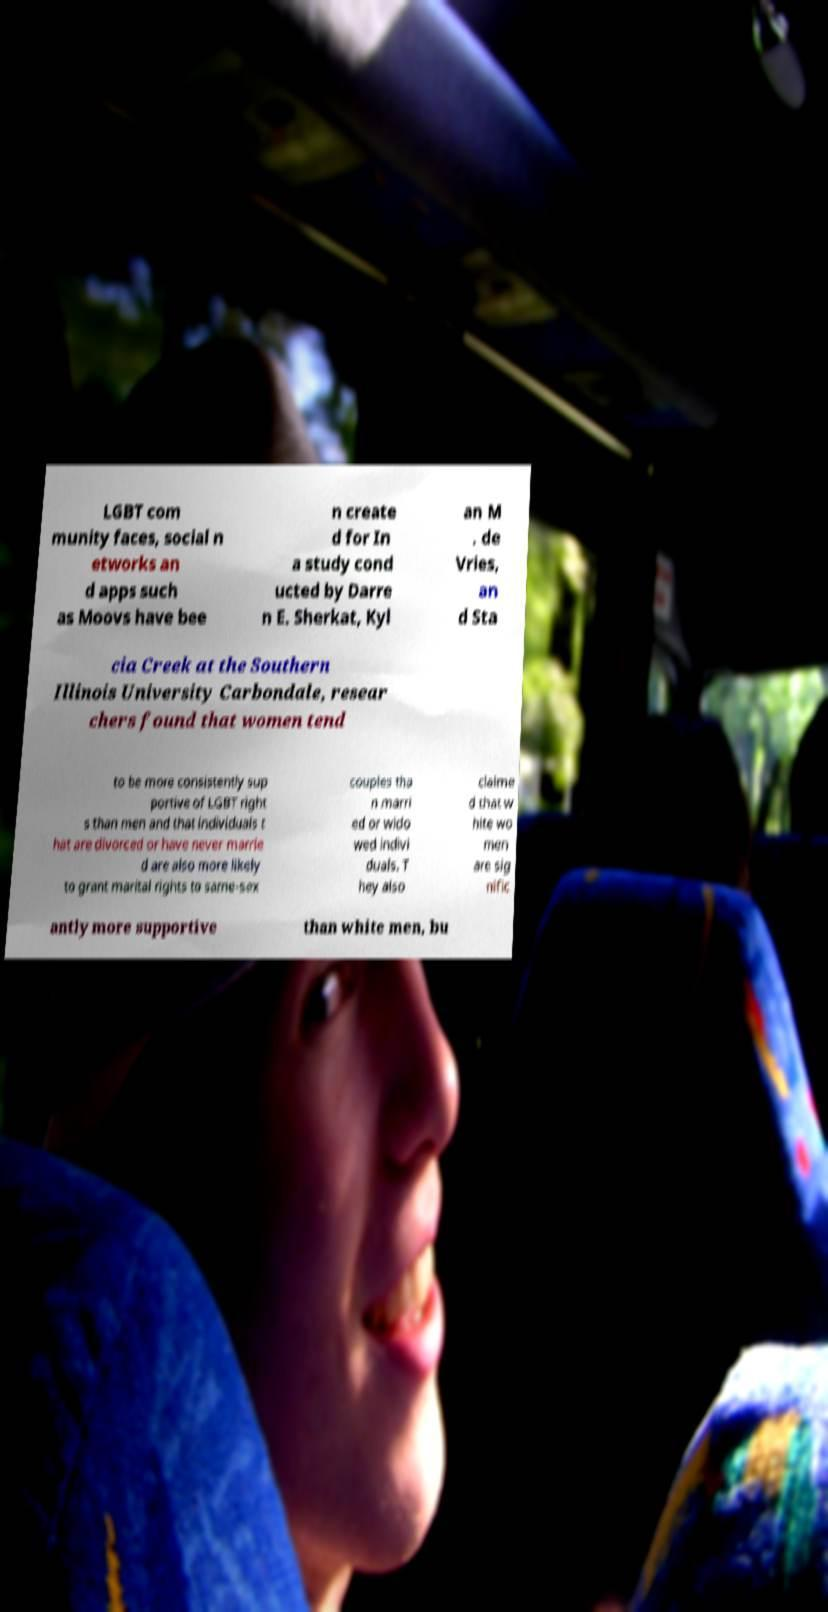I need the written content from this picture converted into text. Can you do that? LGBT com munity faces, social n etworks an d apps such as Moovs have bee n create d for In a study cond ucted by Darre n E. Sherkat, Kyl an M . de Vries, an d Sta cia Creek at the Southern Illinois University Carbondale, resear chers found that women tend to be more consistently sup portive of LGBT right s than men and that individuals t hat are divorced or have never marrie d are also more likely to grant marital rights to same-sex couples tha n marri ed or wido wed indivi duals. T hey also claime d that w hite wo men are sig nific antly more supportive than white men, bu 